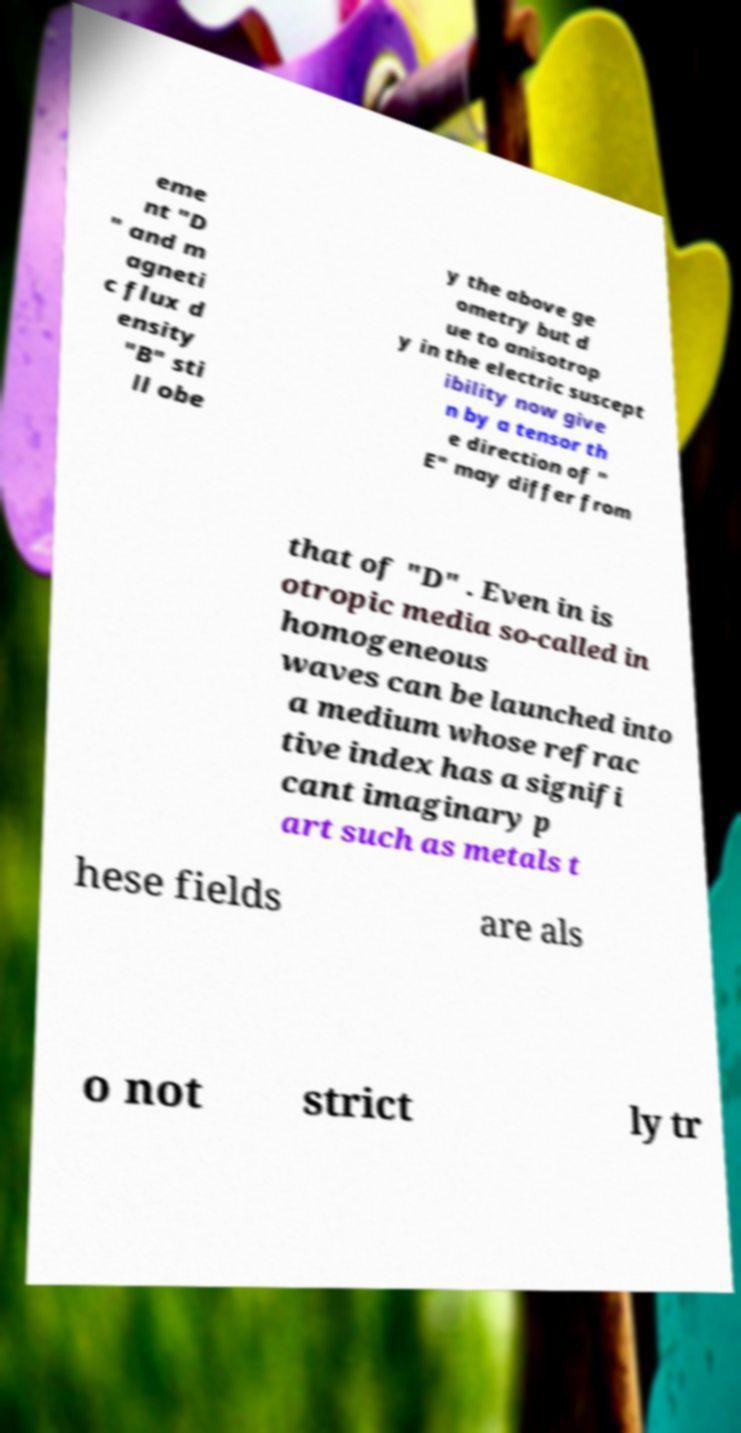What messages or text are displayed in this image? I need them in a readable, typed format. eme nt "D " and m agneti c flux d ensity "B" sti ll obe y the above ge ometry but d ue to anisotrop y in the electric suscept ibility now give n by a tensor th e direction of " E" may differ from that of "D" . Even in is otropic media so-called in homogeneous waves can be launched into a medium whose refrac tive index has a signifi cant imaginary p art such as metals t hese fields are als o not strict ly tr 